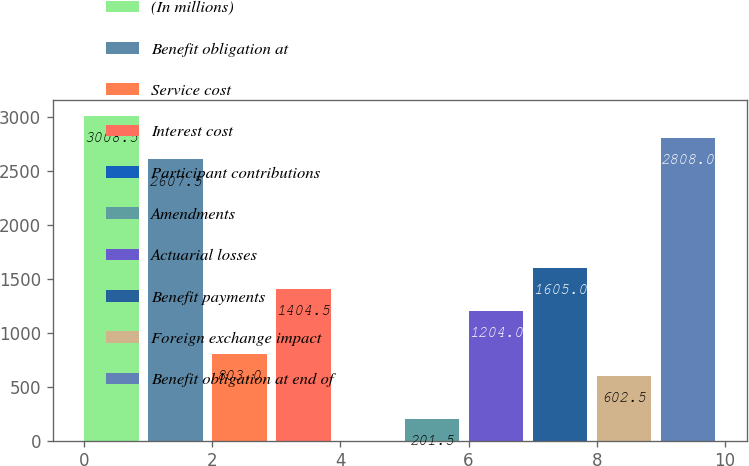Convert chart. <chart><loc_0><loc_0><loc_500><loc_500><bar_chart><fcel>(In millions)<fcel>Benefit obligation at<fcel>Service cost<fcel>Interest cost<fcel>Participant contributions<fcel>Amendments<fcel>Actuarial losses<fcel>Benefit payments<fcel>Foreign exchange impact<fcel>Benefit obligation at end of<nl><fcel>3008.5<fcel>2607.5<fcel>803<fcel>1404.5<fcel>1<fcel>201.5<fcel>1204<fcel>1605<fcel>602.5<fcel>2808<nl></chart> 